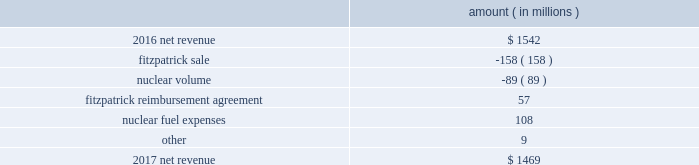The regulatory credit resulting from reduction of the federal corporate income tax rate variance is due to the reduction of the vidalia purchased power agreement regulatory liability by $ 30.5 million and the reduction of the louisiana act 55 financing savings obligation regulatory liabilities by $ 25 million as a result of the enactment of the tax cuts and jobs act , in december 2017 , which lowered the federal corporate income tax rate from 35% ( 35 % ) to 21% ( 21 % ) .
The effects of the tax cuts and jobs act are discussed further in note 3 to the financial statements .
The grand gulf recovery variance is primarily due to increased recovery of higher operating costs .
The louisiana act 55 financing savings obligation variance results from a regulatory charge in 2016 for tax savings to be shared with customers per an agreement approved by the lpsc .
The tax savings resulted from the 2010-2011 irs audit settlement on the treatment of the louisiana act 55 financing of storm costs for hurricane gustav and hurricane ike .
See note 3 to the financial statements for additional discussion of the settlement and benefit sharing .
The volume/weather variance is primarily due to the effect of less favorable weather on residential and commercial sales , partially offset by an increase in industrial usage .
The increase in industrial usage is primarily due to new customers in the primary metals industry and expansion projects and an increase in demand for existing customers in the chlor-alkali industry .
Entergy wholesale commodities following is an analysis of the change in net revenue comparing 2017 to 2016 .
Amount ( in millions ) .
As shown in the table above , net revenue for entergy wholesale commodities decreased by approximately $ 73 million in 2017 primarily due to the absence of net revenue from the fitzpatrick plant after it was sold to exelon in march 2017 and lower volume in the entergy wholesale commodities nuclear fleet resulting from more outage days in 2017 as compared to 2016 .
The decrease was partially offset by an increase resulting from the reimbursement agreement with exelon pursuant to which exelon reimbursed entergy for specified out-of-pocket costs associated with preparing for the refueling and operation of fitzpatrick that otherwise would have been avoided had entergy shut down fitzpatrick in january 2017 and a decrease in nuclear fuel expenses primarily related to the impairments of the indian point 2 , indian point 3 , and palisades plants and related assets .
Revenues received from exelon in 2017 under the reimbursement agreement are offset by other operation and maintenance expenses and taxes other than income taxes and had no effect on net income .
See note 14 to the financial statements for discussion of the sale of fitzpatrick , the reimbursement agreement with exelon , and the impairments and related charges .
Entergy corporation and subsidiaries management 2019s financial discussion and analysis .
What is the growth rate in net revenue in 2017? 
Computations: ((1469 - 1542) / 1542)
Answer: -0.04734. 